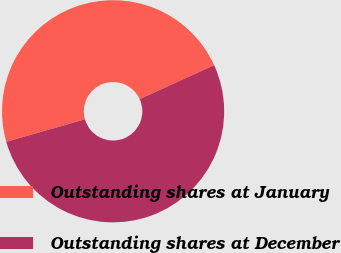<chart> <loc_0><loc_0><loc_500><loc_500><pie_chart><fcel>Outstanding shares at January<fcel>Outstanding shares at December<nl><fcel>47.62%<fcel>52.38%<nl></chart> 